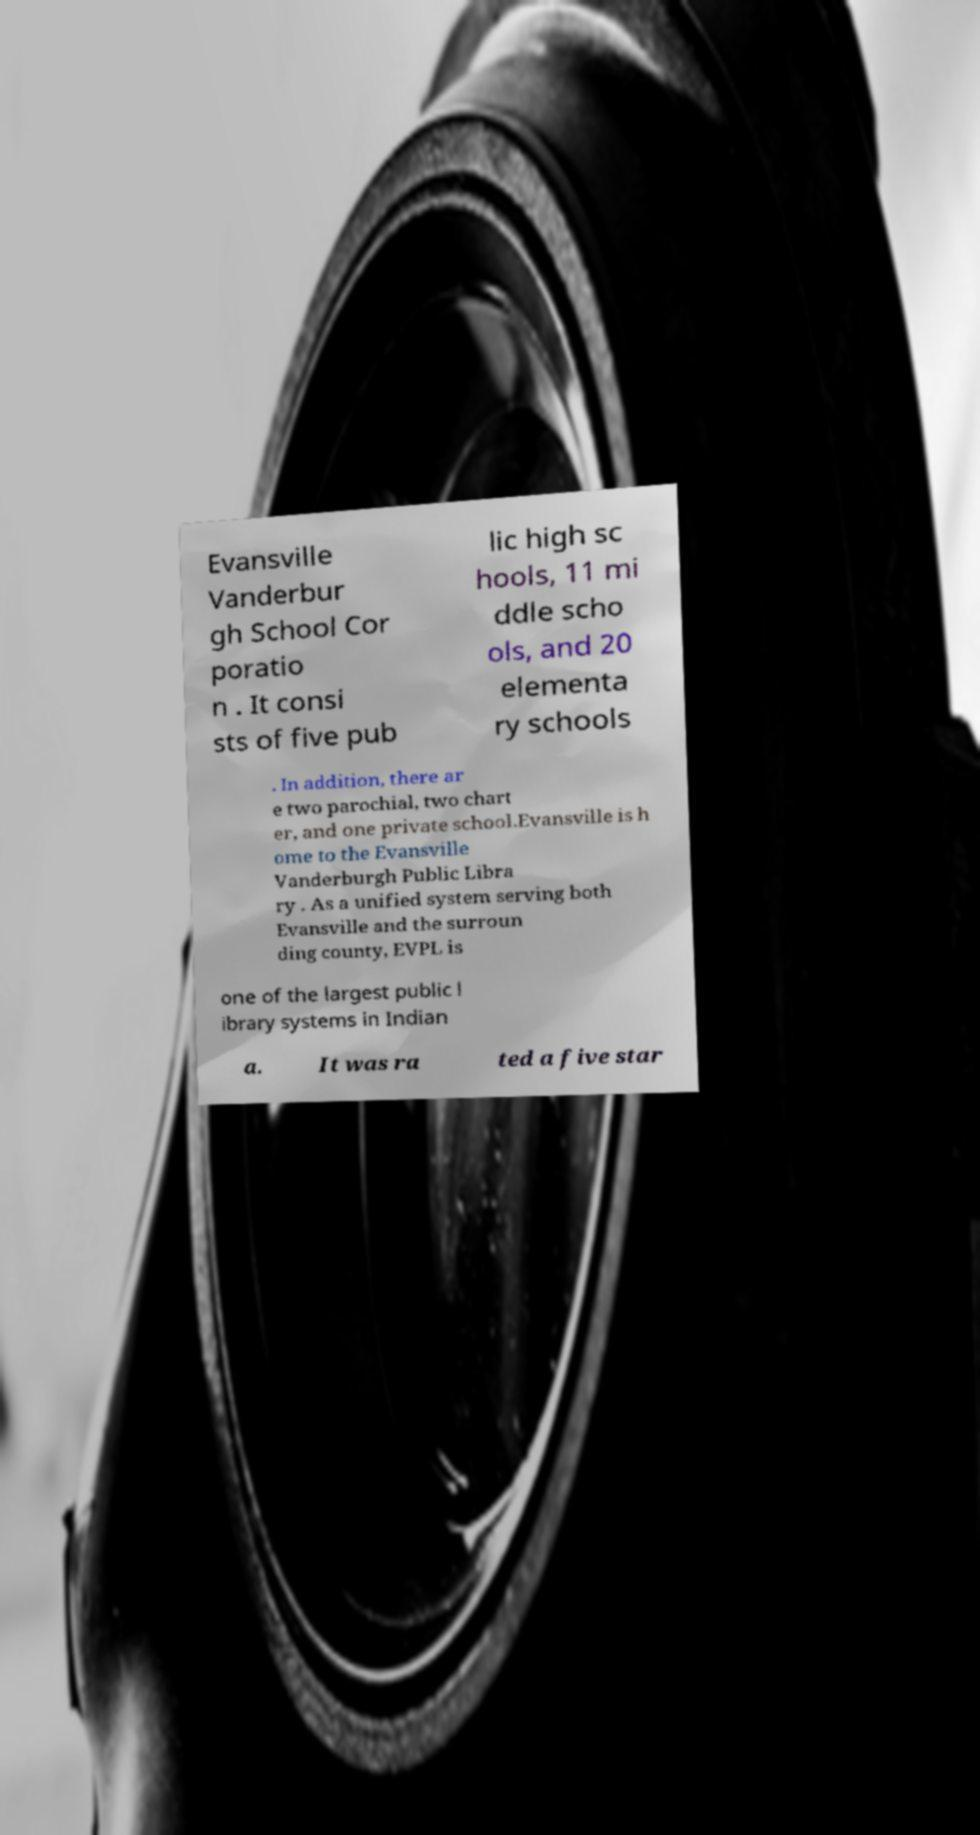Could you extract and type out the text from this image? Evansville Vanderbur gh School Cor poratio n . It consi sts of five pub lic high sc hools, 11 mi ddle scho ols, and 20 elementa ry schools . In addition, there ar e two parochial, two chart er, and one private school.Evansville is h ome to the Evansville Vanderburgh Public Libra ry . As a unified system serving both Evansville and the surroun ding county, EVPL is one of the largest public l ibrary systems in Indian a. It was ra ted a five star 